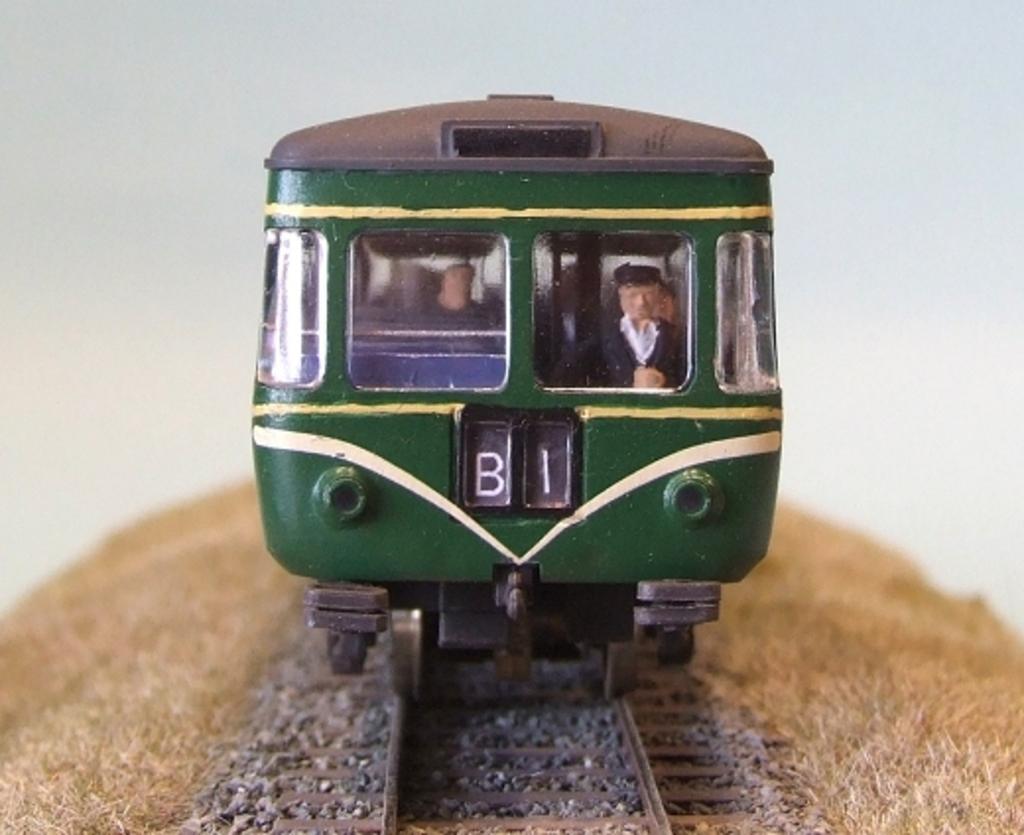Describe this image in one or two sentences. In this image we can see a toy locomotive on the track. In the background there is grass. 